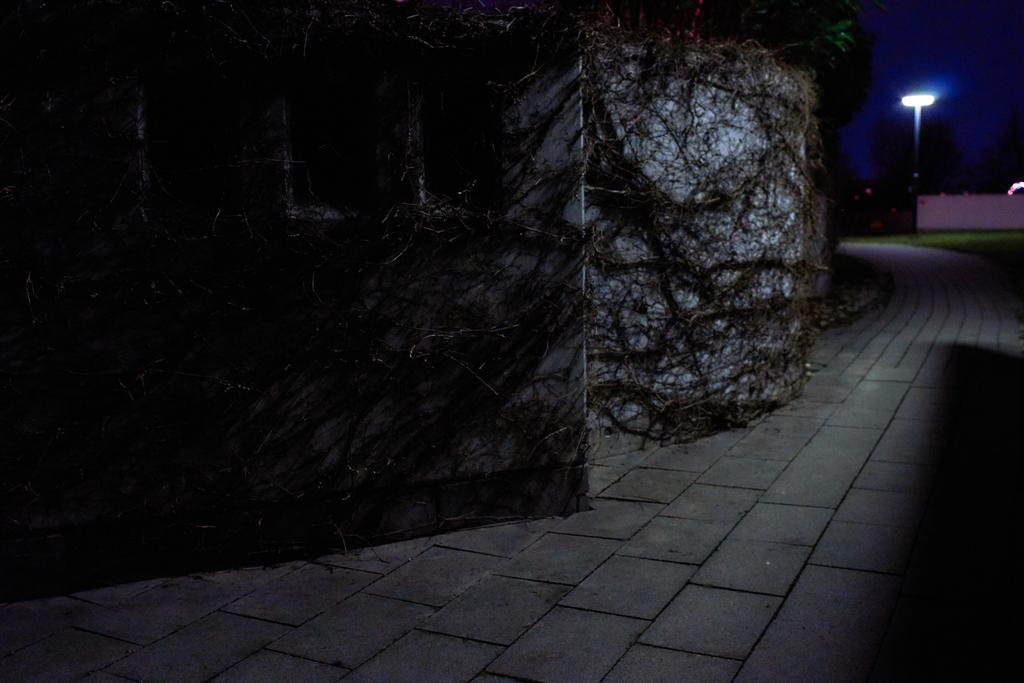What is growing on the wall in the image? There are roots on the wall in the image. What can be seen in the image that people might walk on? There is a walkway in the image. What type of vegetation is present in the image? There is green grass in the image. Where is the street light located in the image? The street light is at the top right corner of the image. Where is the toothbrush located in the image? There is no toothbrush present in the image. What type of mailbox can be seen near the walkway? There is no mailbox present in the image. 